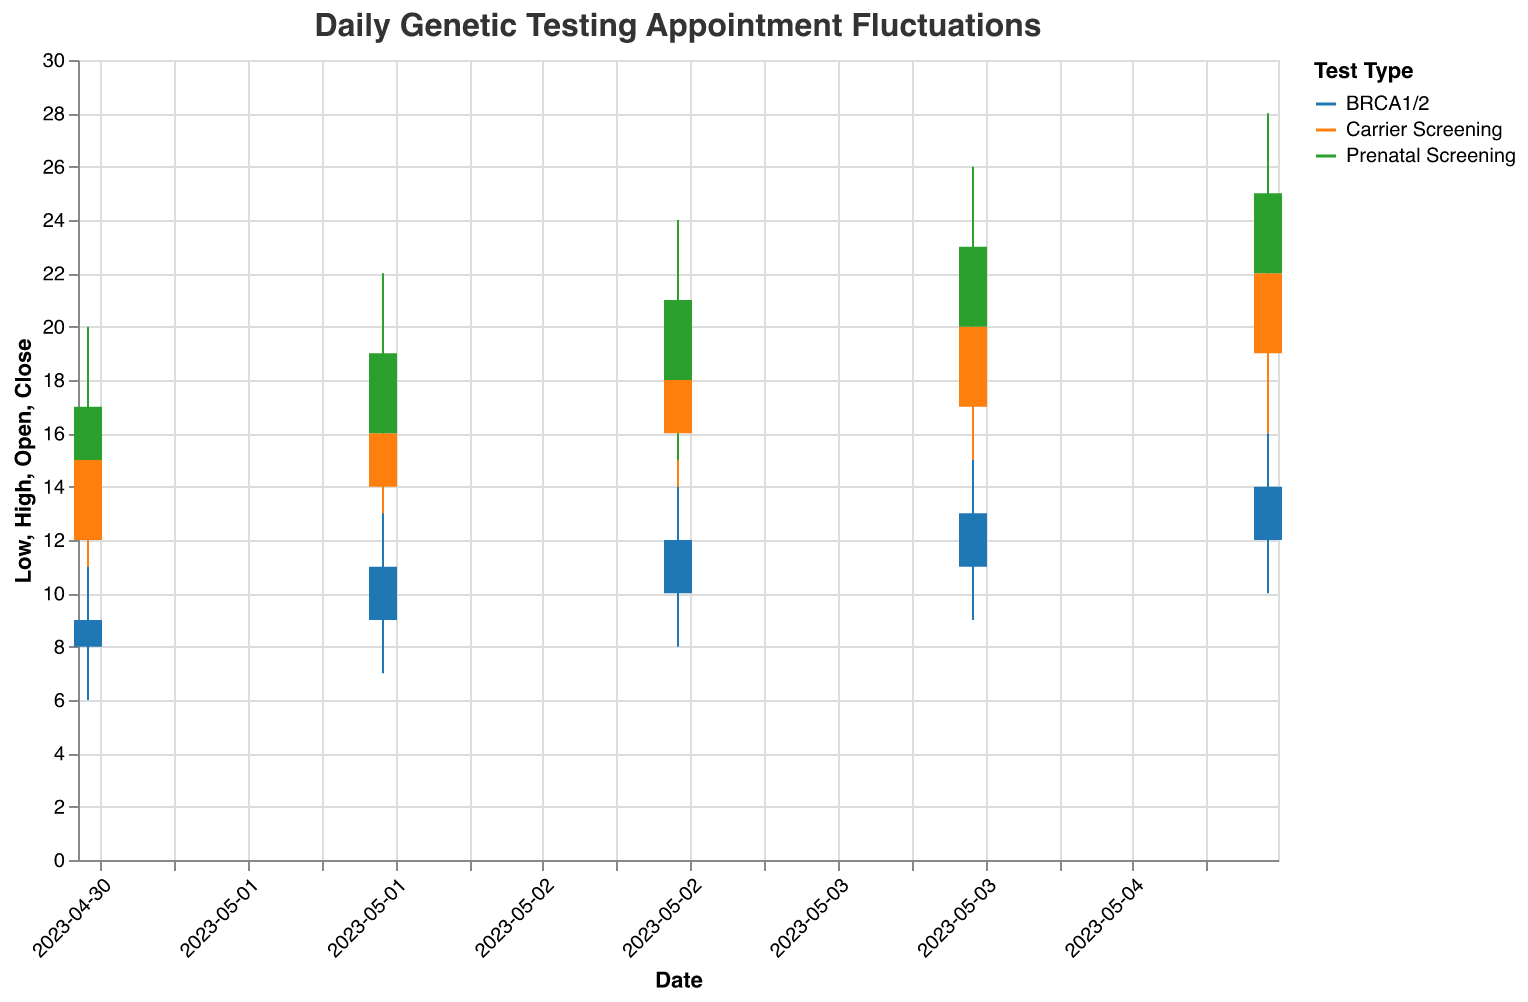What is the title of the figure? The title is displayed at the top of the figure, which indicates the overall subject. It reads "Daily Genetic Testing Appointment Fluctuations".
Answer: Daily Genetic Testing Appointment Fluctuations Which test type had the highest Close value on May 5, 2023? On May 5, 2023, the three test types have different Close values. Carrier Screening closed at 22, BRCA1/2 closed at 14, and Prenatal Screening closed at 25. The highest of these is Prenatal Screening with a value of 25.
Answer: Prenatal Screening What is the range of the Prenatal Screening test type on May 4, 2023? For the Prenatal Screening test on May 4, 2023, the High value is 26 and the Low value is 17. The range is calculated by subtracting the Low value from the High value: 26 - 17 = 9.
Answer: 9 Which test type showed a rise from Open to Close on May 1, 2023? Checking the values: Carrier Screening opened at 12 and closed at 15 (rise), BRCA1/2 opened at 8 and closed at 9 (rise), and Prenatal Screening opened at 15 and closed at 17 (rise). All three test types showed a rise on May 1, 2023.
Answer: Carrier Screening, BRCA1/2, Prenatal Screening How does the Close value of Carrier Screening on May 4, 2023, compare to its Close value on May 1, 2023? The Close value for Carrier Screening was 20 on May 4, 2023, and 15 on May 1, 2023. Comparatively, the Close value on May 4 is higher than on May 1.
Answer: Higher What is the overall trend of the number of Prenatal Screening appointments over the given dates? By examining the Close values for Prenatal Screening from May 1 to May 5 (17, 19, 21, 23, and 25), there is an increasing trend. This indicates an overall upward trend in the number of Prenatal Screening appointments over the given dates.
Answer: Increasing What is the average High value for BRCA1/2 over the 5 days? The High values for BRCA1/2 from May 1 to May 5 are 11, 13, 14, 15, and 16. The sum is 11 + 13 + 14 + 15 + 16 = 69. The average is calculated by dividing this sum by the number of days: 69/5 = 13.8.
Answer: 13.8 Which day saw the largest intra-day fluctuation for Carrier Screening, and what was the value of this fluctuation? The intra-day fluctuation is calculated as High - Low. For Carrier Screening, fluctuations are: May 1 (18-10=8), May 2 (19-11=8), May 3 (21-13=8), May 4 (23-14=9), May 5 (25-16=9). The largest fluctuation was on May 4 and May 5 with a value of 9.
Answer: May 4 and May 5, 9 What is the median Close value for BRCA1/2 across the dates provided? The Close values for BRCA1/2 over the dates are 9, 11, 12, 13, and 14. Arranging these values in ascending order, the median is the middle value in this ordered list, which is 12.
Answer: 12 Between which dates does Prenatal Screening show the highest increase in Close value? The Close values for Prenatal Screening are: May 1 (17), May 2 (19), May 3 (21), May 4 (23), May 5 (25). The differences between consecutive days are: May 2 - May 1 = 2, May 3 - May 2 = 2, May 4 - May 3 = 2, May 5 - May 4 = 2. Since all increases are the same, the highest increase is shared between May 1 to May 2, May 2 to May 3, May 3 to May 4, and May 4 to May 5.
Answer: May 1-2, May 2-3, May 3-4, May 4-5 